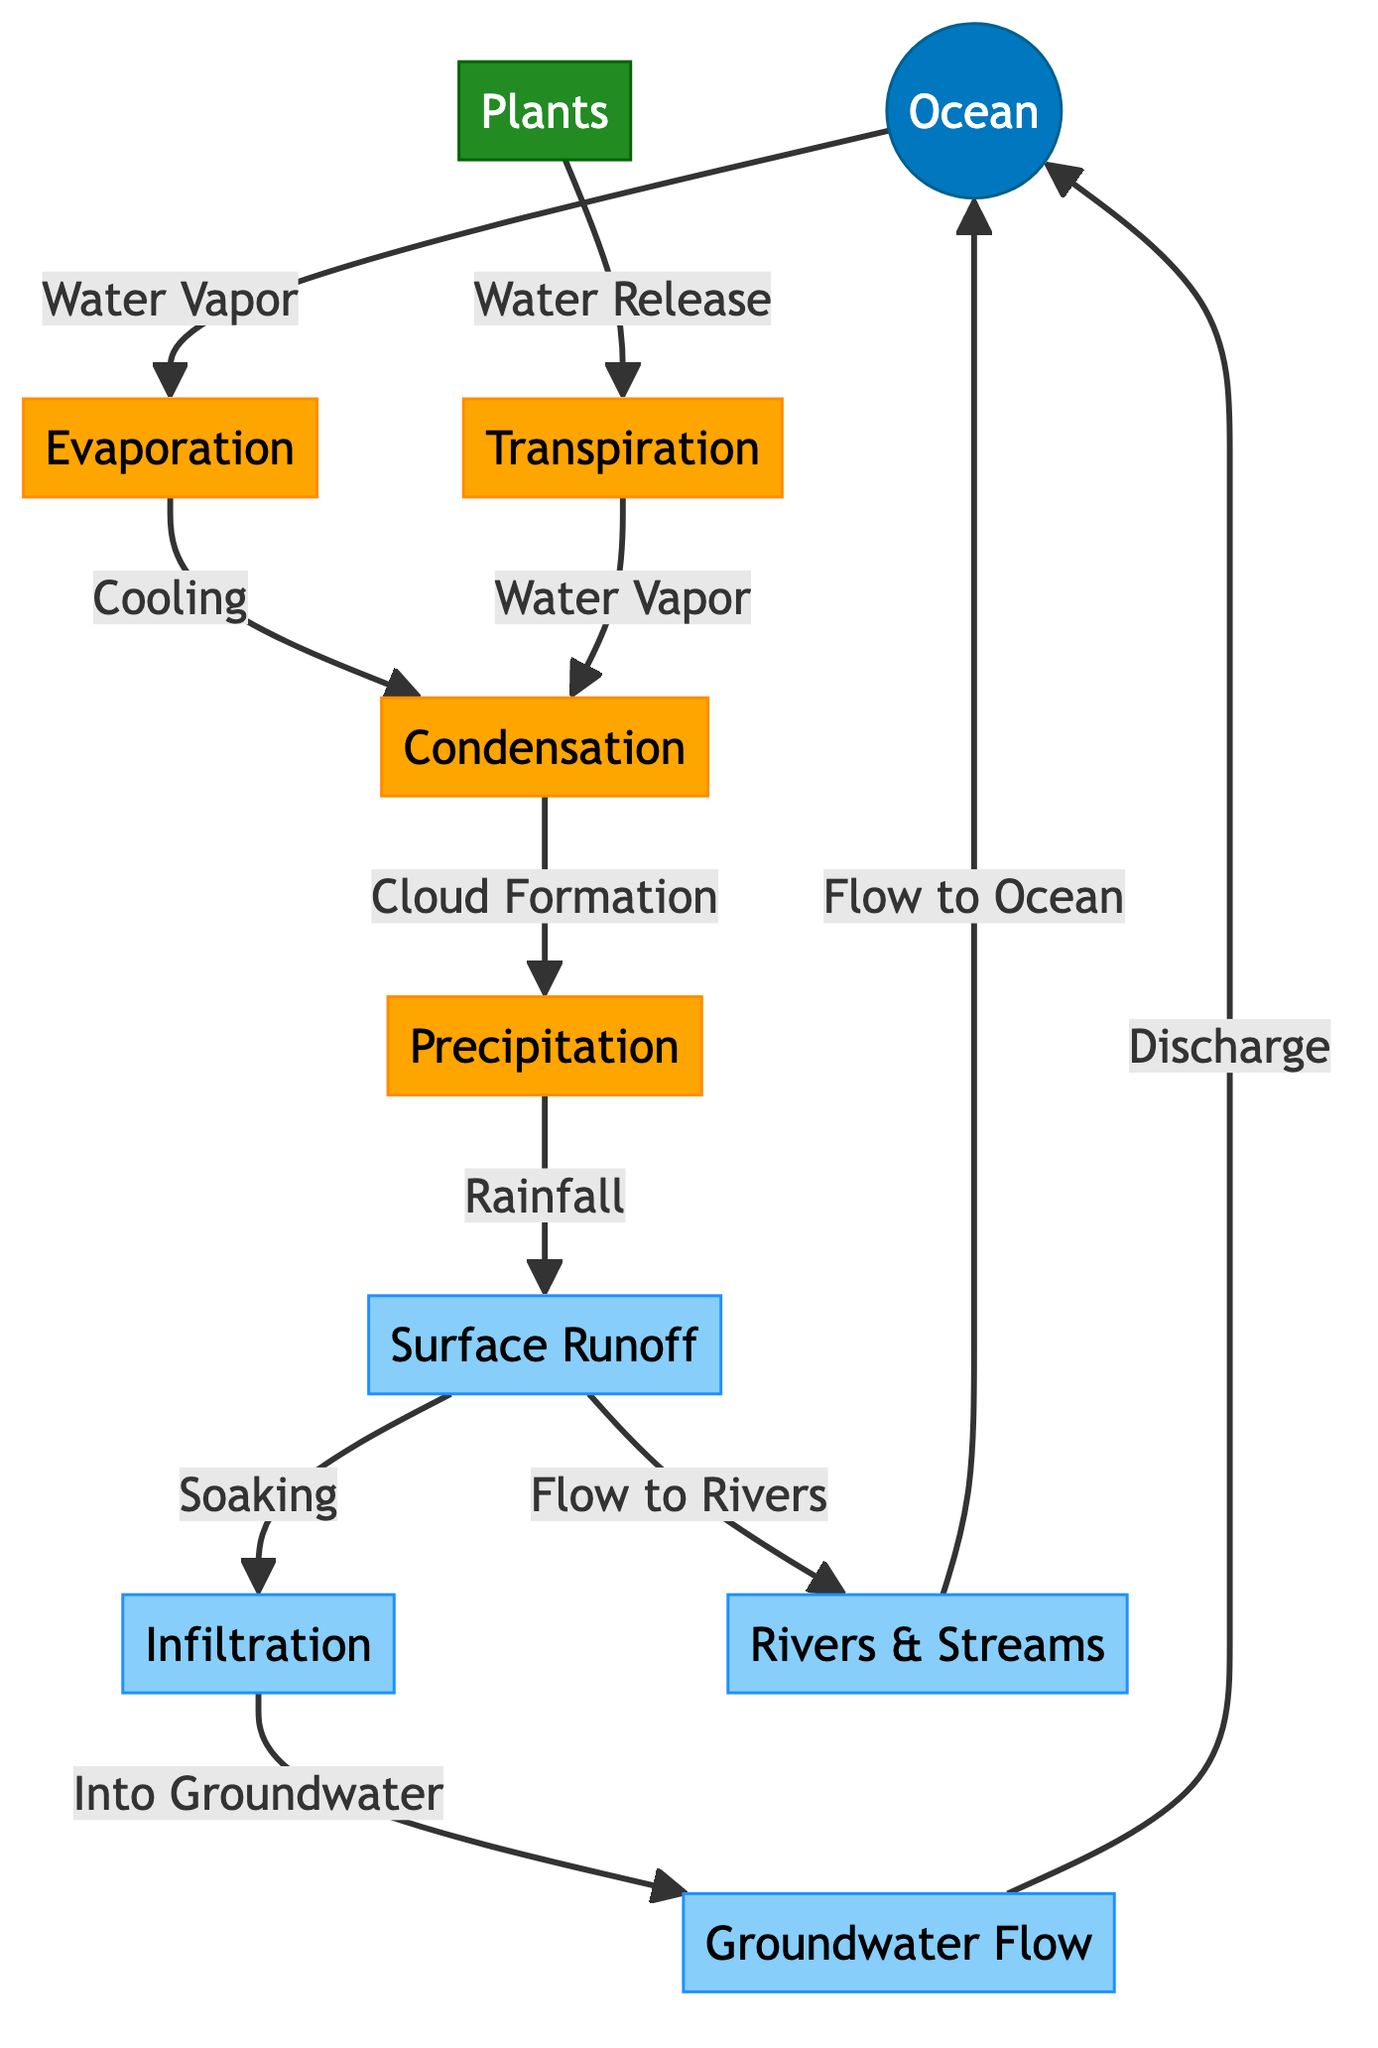What is the first process in the water cycle depicted? The diagram starts with the flow from the ocean producing water vapor through the process of evaporation, which is the first step in the water cycle.
Answer: Evaporation How many processes are shown in the diagram? The diagram includes five distinct processes: evaporation, condensation, precipitation, transpiration, and infiltration. Counting these gives a total of five processes.
Answer: Five Which element returns water to the ocean after flowing through the ground? The flow diagram indicates that groundwater returns to the ocean through a discharge process, meaning groundwater flow contributes to this return.
Answer: Groundwater Flow What step follows condensation in the water cycle? After condensation occurs and results in cloud formation, the next step in the sequence shown is precipitation, which leads to rainfall.
Answer: Precipitation How does water travel from rivers back to the ocean in this diagram? The diagram illustrates that water moves from rivers and streams toward the ocean, indicating a straightforward flow direction connecting these two nodes.
Answer: Flow to Ocean What is the role of plants in the water cycle as depicted? According to the diagram, plants release water vapor into the atmosphere through the process of transpiration, which also connects to condensation.
Answer: Water Release Which process occurs after precipitation, and what two actions result from it? After precipitation, the diagram indicates that surface runoff and infiltration occur. Surface runoff leads water to rivers and streams, while infiltration allows water to soak into the ground.
Answer: Surface Runoff and Infiltration What is the connection between evaporation and condensation in the water cycle? The diagram shows that evaporation produces water vapor, which then cools and leads to condensation, forming clouds. This connection highlights the sequential nature of these two processes.
Answer: Cooling What happens to the groundwater after infiltration? Once groundwater is formed through the process of infiltration, the diagram specifically states that it must then flow, leading to discharge into the ocean, completing the cycle.
Answer: Discharge 